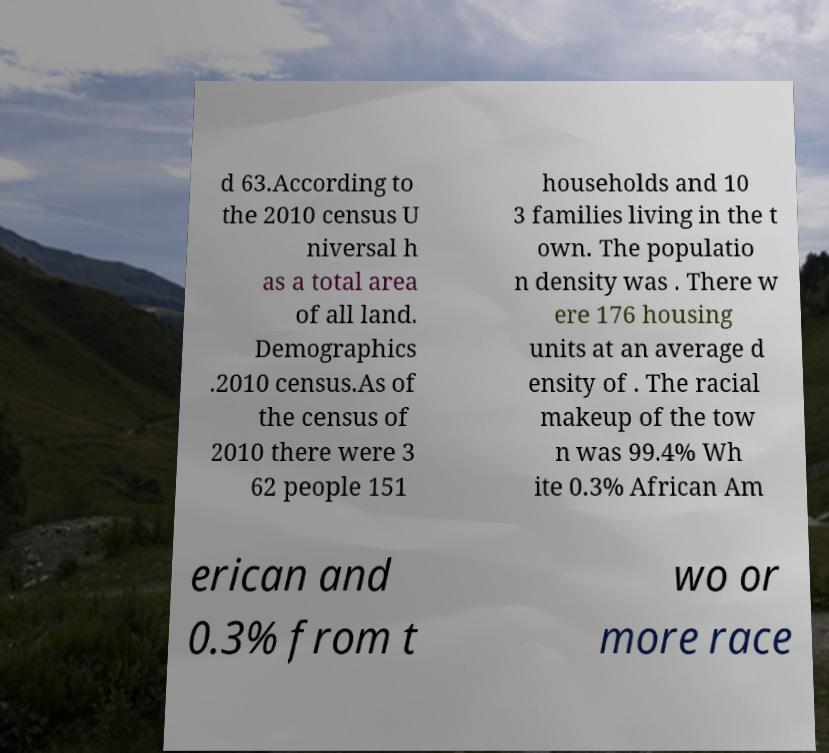Can you read and provide the text displayed in the image?This photo seems to have some interesting text. Can you extract and type it out for me? d 63.According to the 2010 census U niversal h as a total area of all land. Demographics .2010 census.As of the census of 2010 there were 3 62 people 151 households and 10 3 families living in the t own. The populatio n density was . There w ere 176 housing units at an average d ensity of . The racial makeup of the tow n was 99.4% Wh ite 0.3% African Am erican and 0.3% from t wo or more race 